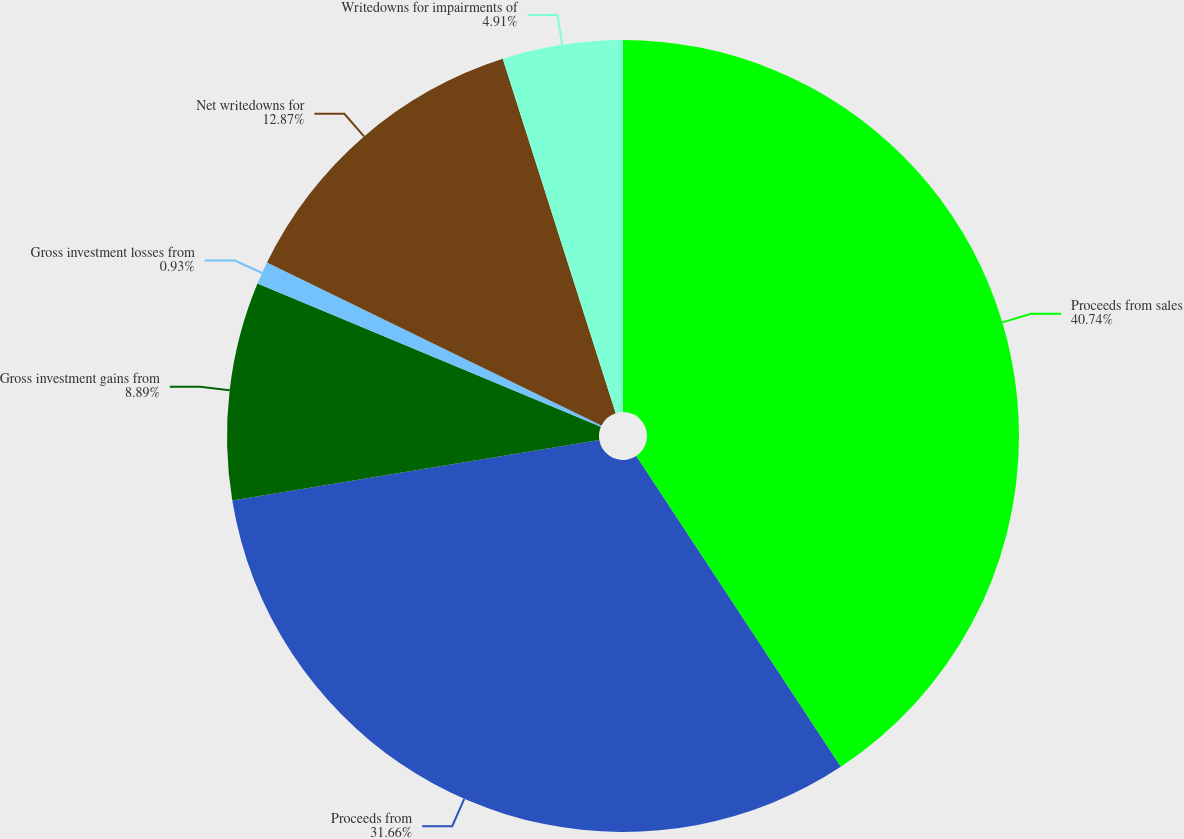Convert chart. <chart><loc_0><loc_0><loc_500><loc_500><pie_chart><fcel>Proceeds from sales<fcel>Proceeds from<fcel>Gross investment gains from<fcel>Gross investment losses from<fcel>Net writedowns for<fcel>Writedowns for impairments of<nl><fcel>40.73%<fcel>31.66%<fcel>8.89%<fcel>0.93%<fcel>12.87%<fcel>4.91%<nl></chart> 